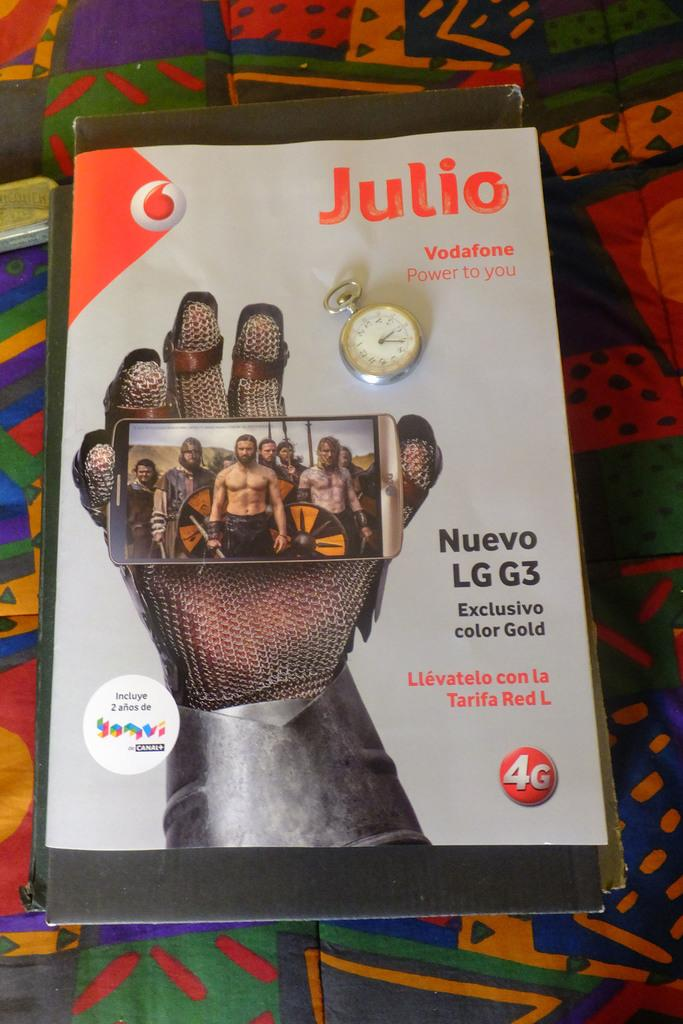<image>
Provide a brief description of the given image. A poster displays the new LG G3 and advertises a 4G network. 